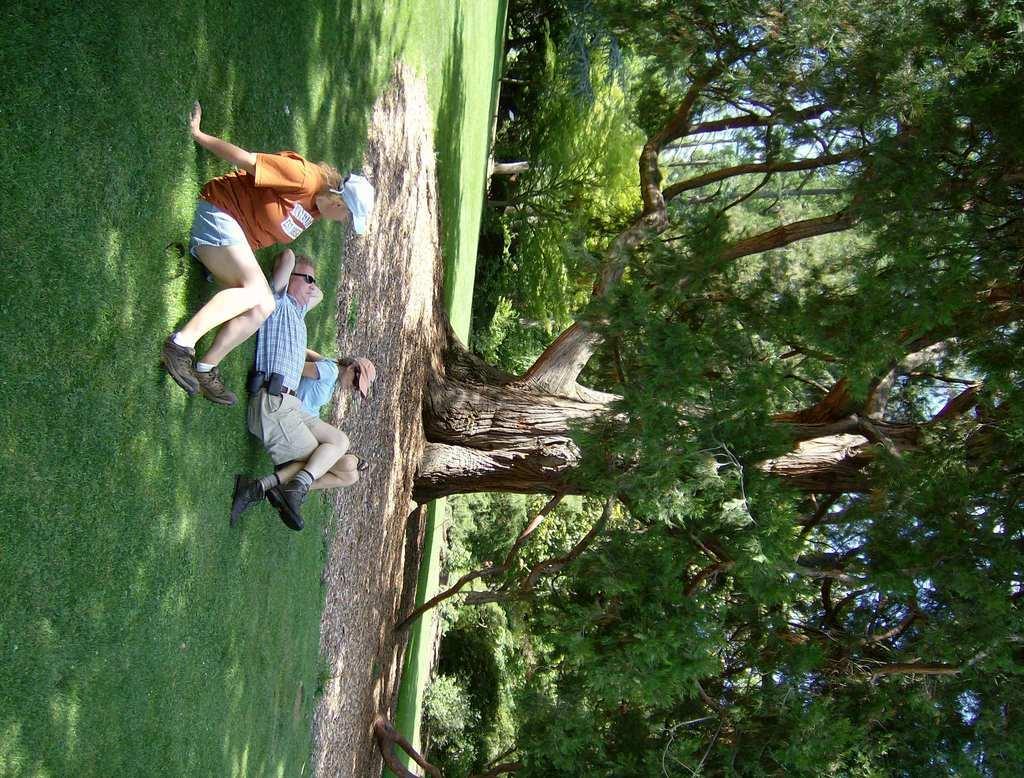How would you summarize this image in a sentence or two? It is the vertical image in which there is a man sleeping on the ground. Beside him there are two women who are sitting on the ground. In the background there are trees. 